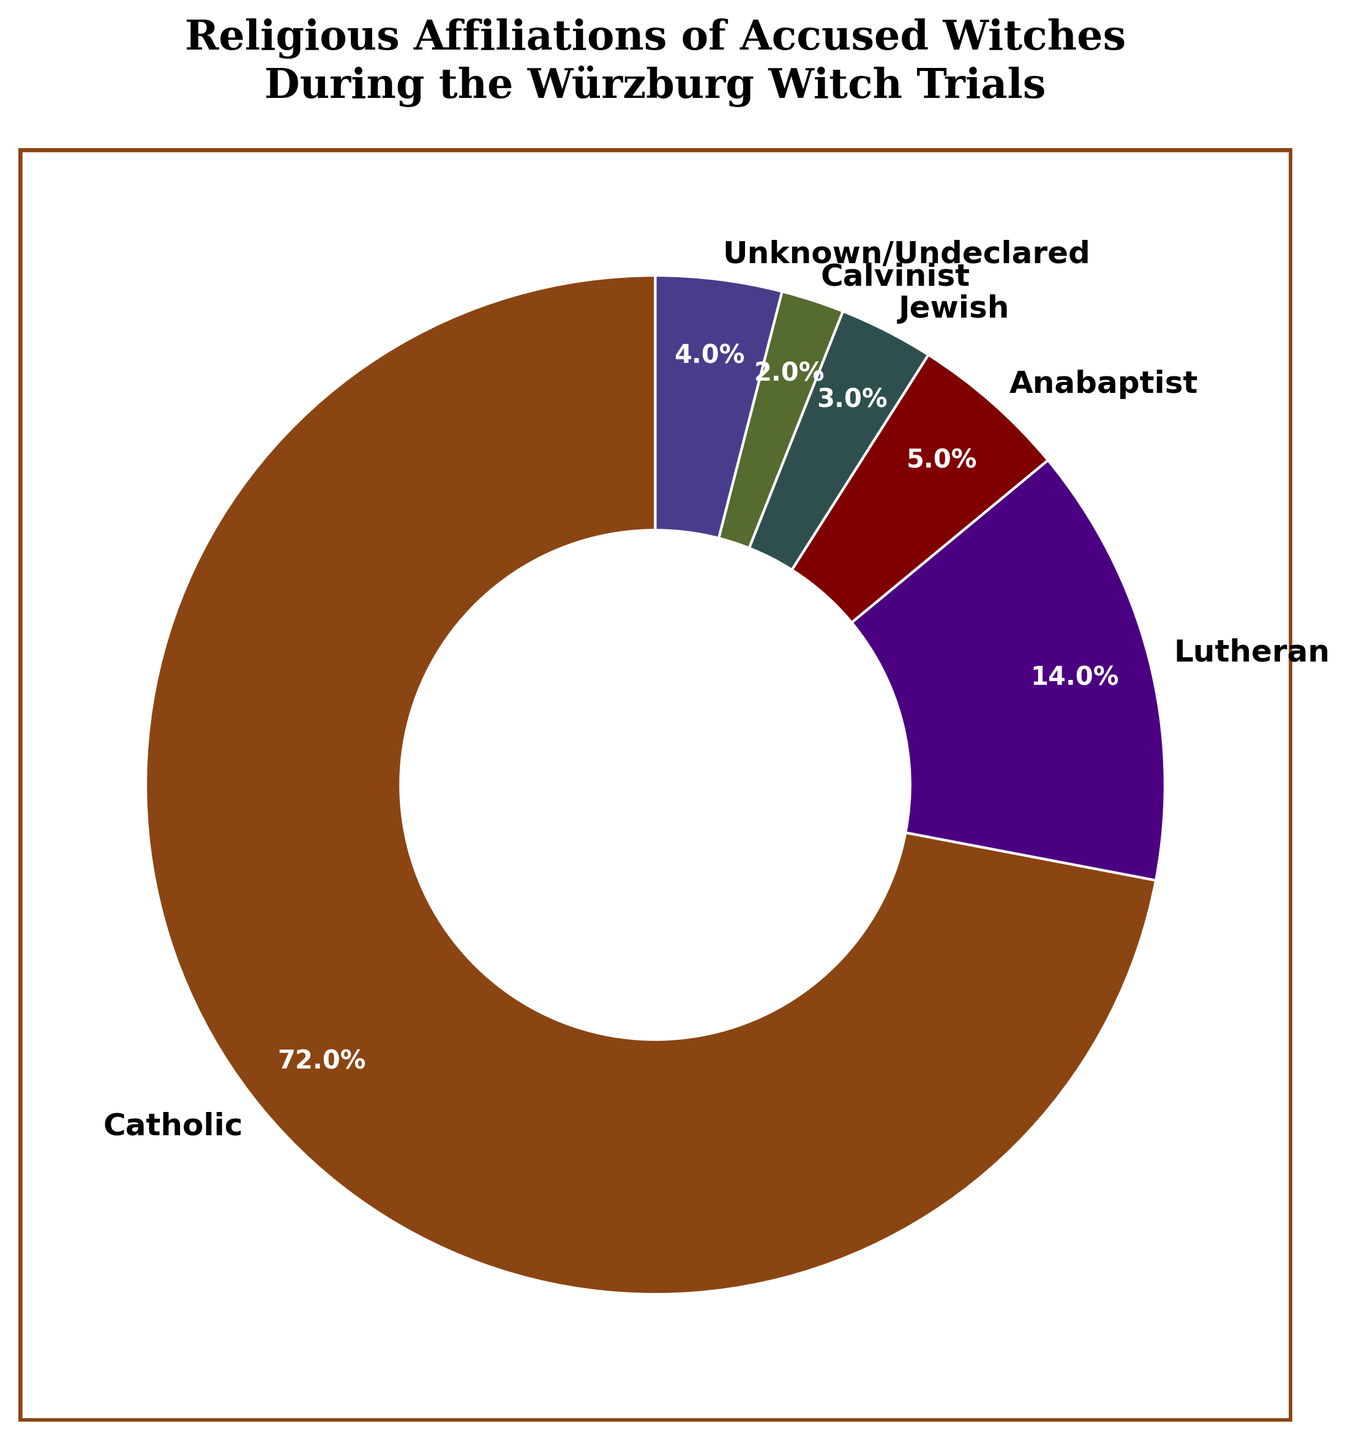What percentage of the accused witches were Catholic? The pie chart depicts that the segment labeled "Catholic" represents 72% of the total accused witches.
Answer: 72% Which religious group had the second highest percentage of accused witches during the Würzburg witch trials? By examining the pie chart, the segment labeled "Lutheran" has the second largest percentage after "Catholic" at 14%.
Answer: Lutheran What is the combined percentage of Anabaptists and Calvinists among the accused witches? The percentages for Anabaptists and Calvinists are 5% and 2%, respectively. Adding these values gives 5% + 2% = 7%.
Answer: 7% Compare the proportion of accused witches who were Jewish to those who were Anabaptist. Looking at the chart, the segment for Jewish accused witches is 3% while the segment for Anabaptist accused witches is 5%. Comparing these, 5% (Anabaptist) is greater than 3% (Jewish).
Answer: Anabaptist is greater than Jewish What percentage of the accused witches did not declare their religion or whose religion was unknown? The pie chart shows that the segment labeled "Unknown/Undeclared" forms 4% of the total.
Answer: 4% Are there more accused witches who were Calvinist or unknown/undeclared? By comparing the respective segments, Calvinists make up 2% while those with unknown/undeclared religion make up 4%. Therefore, there are more unknown/undeclared.
Answer: Unknown/Undeclared What is the total percentage of accused witches belonging to Lutheran, Jewish, and Anabaptist religious groups combined? Summing up their individual percentages: Lutheran (14%) + Jewish (3%) + Anabaptist (5%) results in 14% + 3% + 5% = 22%.
Answer: 22% Which segment in the pie chart is represented by the darkest shade? The segment with the darkest shade represents the "Calvinist" group, as inferred from the subdued and deep color used.
Answer: Calvinist Of the groups depicted, which religious affiliation had the smallest representation among the accused witches? From the pie chart, the "Calvinist" group has the smallest representation with 2%.
Answer: Calvinist How much larger is the proportion of Catholic accused witches compared to the Unknown/Undeclared group? The percentage for Catholics is 72%, and for Unknown/Undeclared it is 4%. The difference is 72% - 4% = 68%.
Answer: 68% 